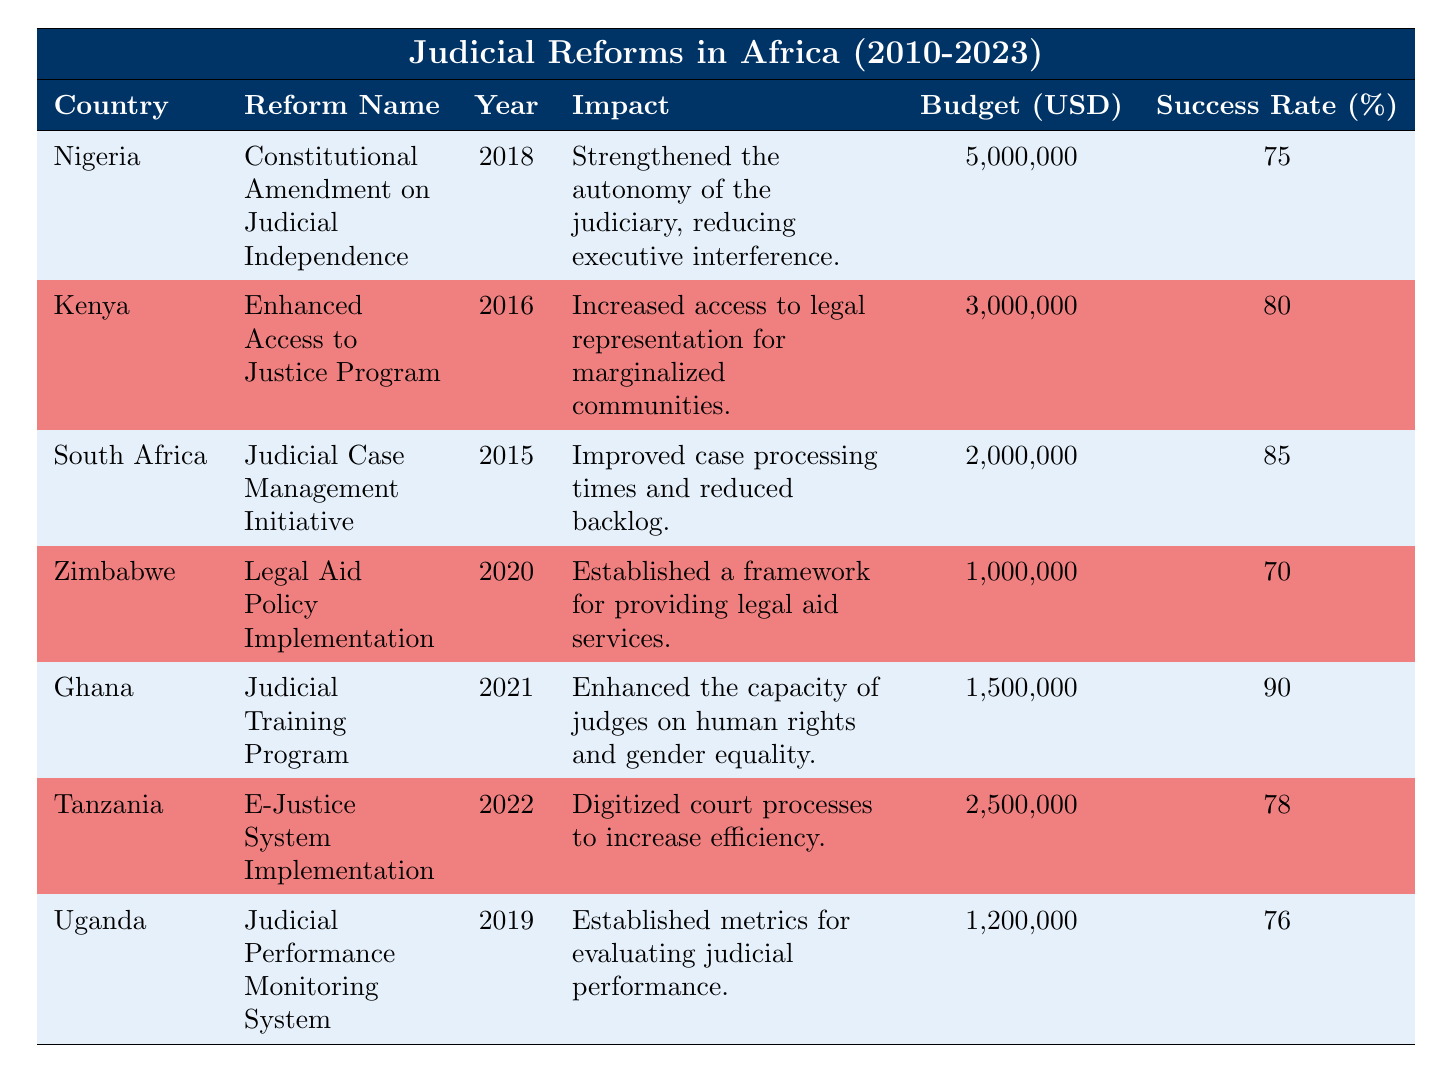What is the budget allocated for the Judicial Case Management Initiative in South Africa? The table shows that the budget allocated for the Judicial Case Management Initiative in South Africa is listed under the Budget (USD) column, which states 2,000,000.
Answer: 2,000,000 Which country's judicial reform has the highest success rate? Reviewing the Success Rate (%) column, Ghana has the highest success rate at 90%.
Answer: Ghana Is the budget allocated for Legal Aid Policy Implementation in Zimbabwe greater than 1 million USD? The table indicates that the budget allocated for Legal Aid Policy Implementation in Zimbabwe is exactly 1,000,000. Therefore, the answer is no since it is not greater than 1 million.
Answer: No What is the average success rate of the reforms listed in the table? To find the average success rate, we add all the success rates: (75 + 80 + 85 + 70 + 90 + 78 + 76) = 534. There are 7 reforms, so the average is 534/7, which equals approximately 76.29.
Answer: 76.29 Did any of the reforms implemented after 2018 have a success rate below 75%? The reforms after 2018 are in Nigeria (75% - exactly), Zimbabwe (70%), Ghana (90%), Tanzania (78%), and Uganda (76%). Among these, Zimbabwe has a success rate below 75%, thus the answer is yes.
Answer: Yes What is the total amount allocated for the reforms in 2016 and 2022? The table shows that the budget for the Enhanced Access to Justice Program in 2016 is 3,000,000 and for the E-Justice System Implementation in 2022 is 2,500,000. Adding these together gives 3,000,000 + 2,500,000 = 5,500,000.
Answer: 5,500,000 Which reform had the impact of reducing executive interference in the judiciary? The table indicates that the reform that strengthened the autonomy of the judiciary and reduced executive interference is the Constitutional Amendment on Judicial Independence in Nigeria.
Answer: Constitutional Amendment on Judicial Independence What percentage of the budget was allocated for the E-Justice System Implementation compared to the total budget for all reforms? The total budget for all reforms is 5,000,000 + 3,000,000 + 2,000,000 + 1,000,000 + 1,500,000 + 2,500,000 + 1,200,000 = 16,700,000. The budget for E-Justice System Implementation is 2,500,000. To find the percentage, we calculate (2,500,000 / 16,700,000) * 100, which equals approximately 14.97%.
Answer: 14.97% 